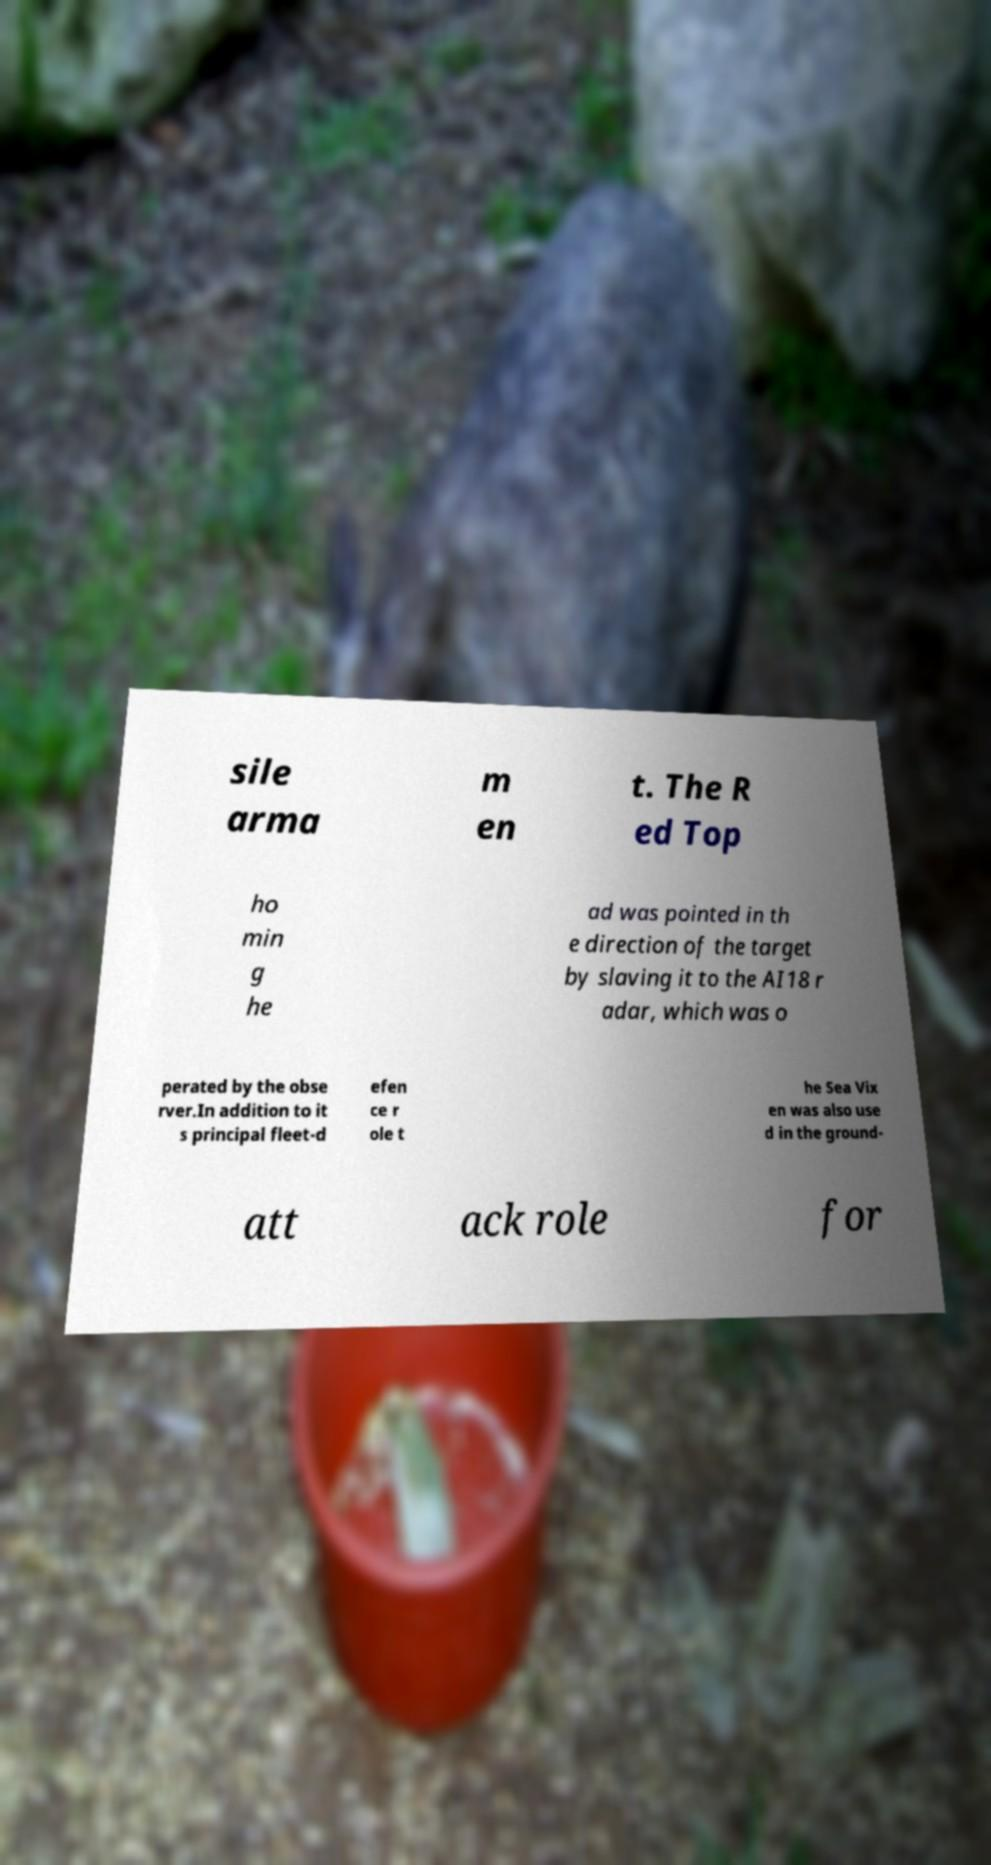For documentation purposes, I need the text within this image transcribed. Could you provide that? sile arma m en t. The R ed Top ho min g he ad was pointed in th e direction of the target by slaving it to the AI18 r adar, which was o perated by the obse rver.In addition to it s principal fleet-d efen ce r ole t he Sea Vix en was also use d in the ground- att ack role for 